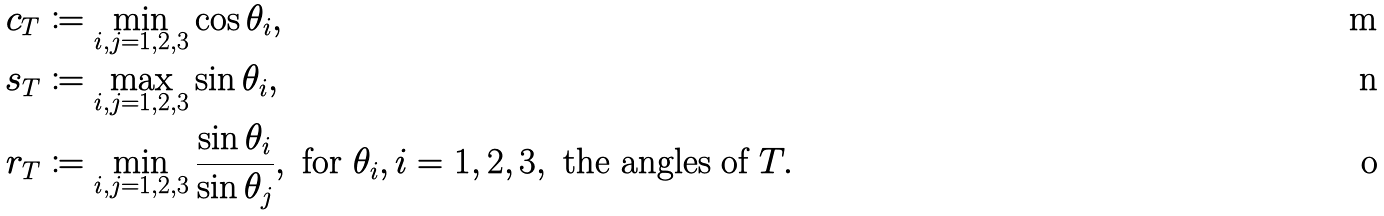Convert formula to latex. <formula><loc_0><loc_0><loc_500><loc_500>c _ { T } & \coloneqq \min _ { i , j = 1 , 2 , 3 } \cos \theta _ { i } , \\ s _ { T } & \coloneqq \max _ { i , j = 1 , 2 , 3 } \sin \theta _ { i } , \\ r _ { T } & \coloneqq \min _ { i , j = 1 , 2 , 3 } \frac { \sin \theta _ { i } } { \sin \theta _ { j } } , \text { for } \theta _ { i } , i = 1 , 2 , 3 , \text { the angles of } T .</formula> 